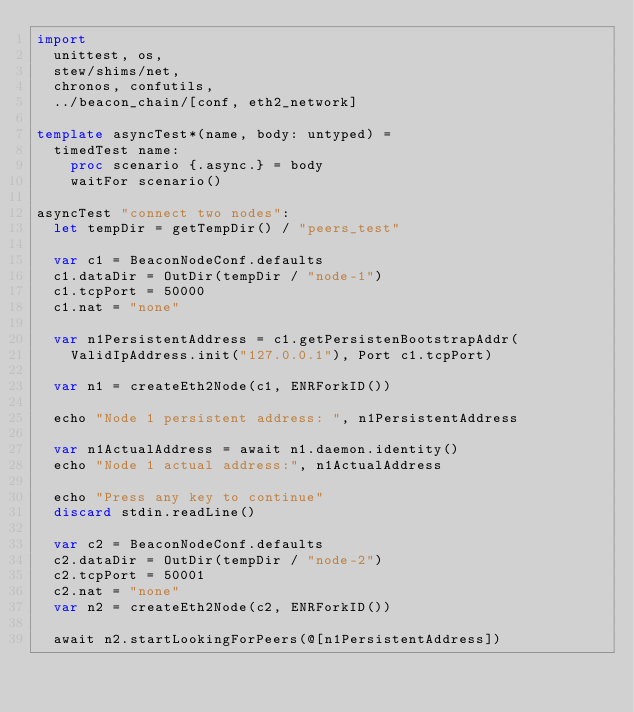<code> <loc_0><loc_0><loc_500><loc_500><_Nim_>import
  unittest, os,
  stew/shims/net,
  chronos, confutils,
  ../beacon_chain/[conf, eth2_network]

template asyncTest*(name, body: untyped) =
  timedTest name:
    proc scenario {.async.} = body
    waitFor scenario()

asyncTest "connect two nodes":
  let tempDir = getTempDir() / "peers_test"

  var c1 = BeaconNodeConf.defaults
  c1.dataDir = OutDir(tempDir / "node-1")
  c1.tcpPort = 50000
  c1.nat = "none"

  var n1PersistentAddress = c1.getPersistenBootstrapAddr(
    ValidIpAddress.init("127.0.0.1"), Port c1.tcpPort)

  var n1 = createEth2Node(c1, ENRForkID())

  echo "Node 1 persistent address: ", n1PersistentAddress

  var n1ActualAddress = await n1.daemon.identity()
  echo "Node 1 actual address:", n1ActualAddress

  echo "Press any key to continue"
  discard stdin.readLine()

  var c2 = BeaconNodeConf.defaults
  c2.dataDir = OutDir(tempDir / "node-2")
  c2.tcpPort = 50001
  c2.nat = "none"
  var n2 = createEth2Node(c2, ENRForkID())

  await n2.startLookingForPeers(@[n1PersistentAddress])

</code> 